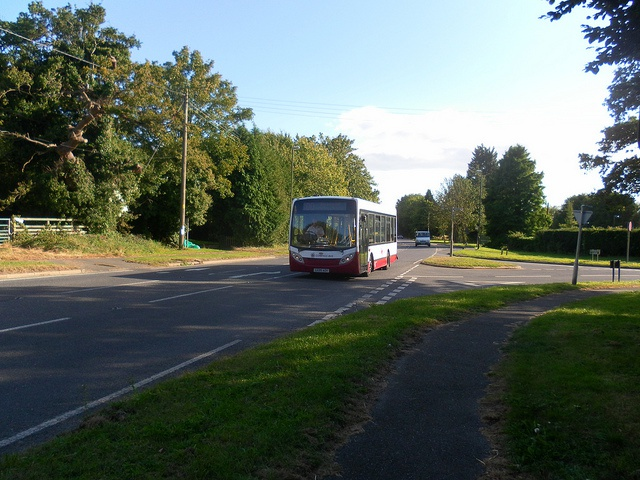Describe the objects in this image and their specific colors. I can see bus in lightblue, black, gray, navy, and white tones, truck in lightblue, navy, gray, and black tones, car in lightblue, navy, gray, and black tones, and car in lightblue, black, and gray tones in this image. 